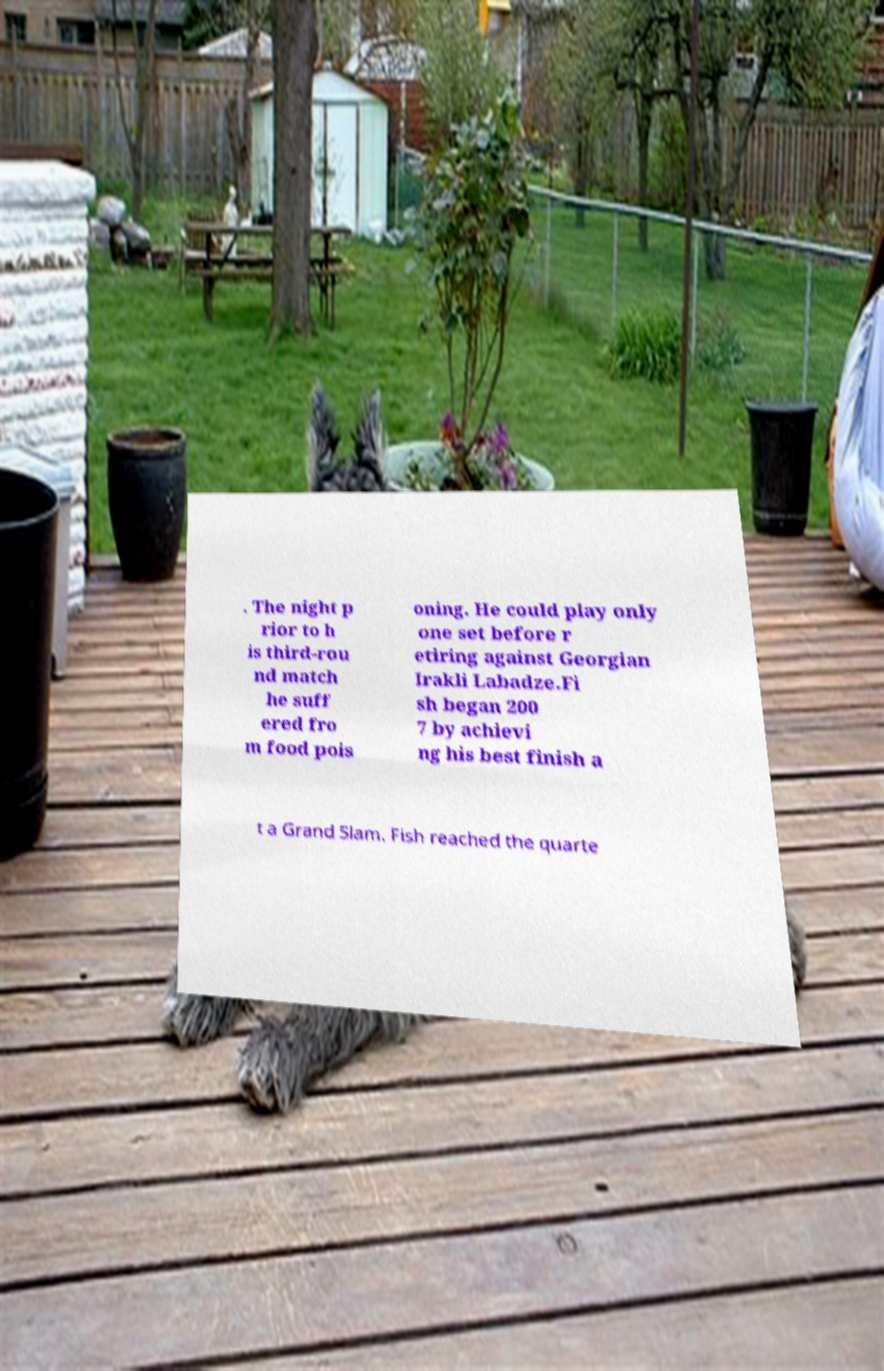Could you assist in decoding the text presented in this image and type it out clearly? . The night p rior to h is third-rou nd match he suff ered fro m food pois oning. He could play only one set before r etiring against Georgian Irakli Labadze.Fi sh began 200 7 by achievi ng his best finish a t a Grand Slam. Fish reached the quarte 